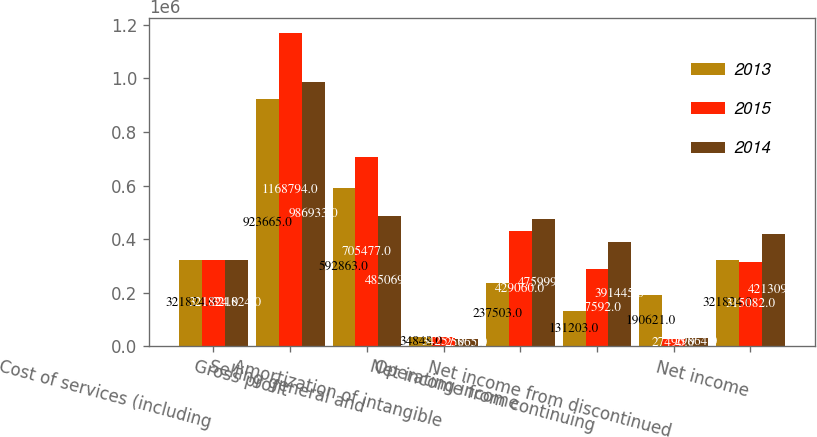Convert chart to OTSL. <chart><loc_0><loc_0><loc_500><loc_500><stacked_bar_chart><ecel><fcel>Cost of services (including<fcel>Gross profit<fcel>Selling general and<fcel>Amortization of intangible<fcel>Operating income<fcel>Net income from continuing<fcel>Net income from discontinued<fcel>Net income<nl><fcel>2013<fcel>321824<fcel>923665<fcel>592863<fcel>34848<fcel>237503<fcel>131203<fcel>190621<fcel>321824<nl><fcel>2015<fcel>321824<fcel>1.16879e+06<fcel>705477<fcel>34257<fcel>429060<fcel>287592<fcel>27490<fcel>315082<nl><fcel>2014<fcel>321824<fcel>986933<fcel>485069<fcel>25865<fcel>475999<fcel>391445<fcel>29864<fcel>421309<nl></chart> 